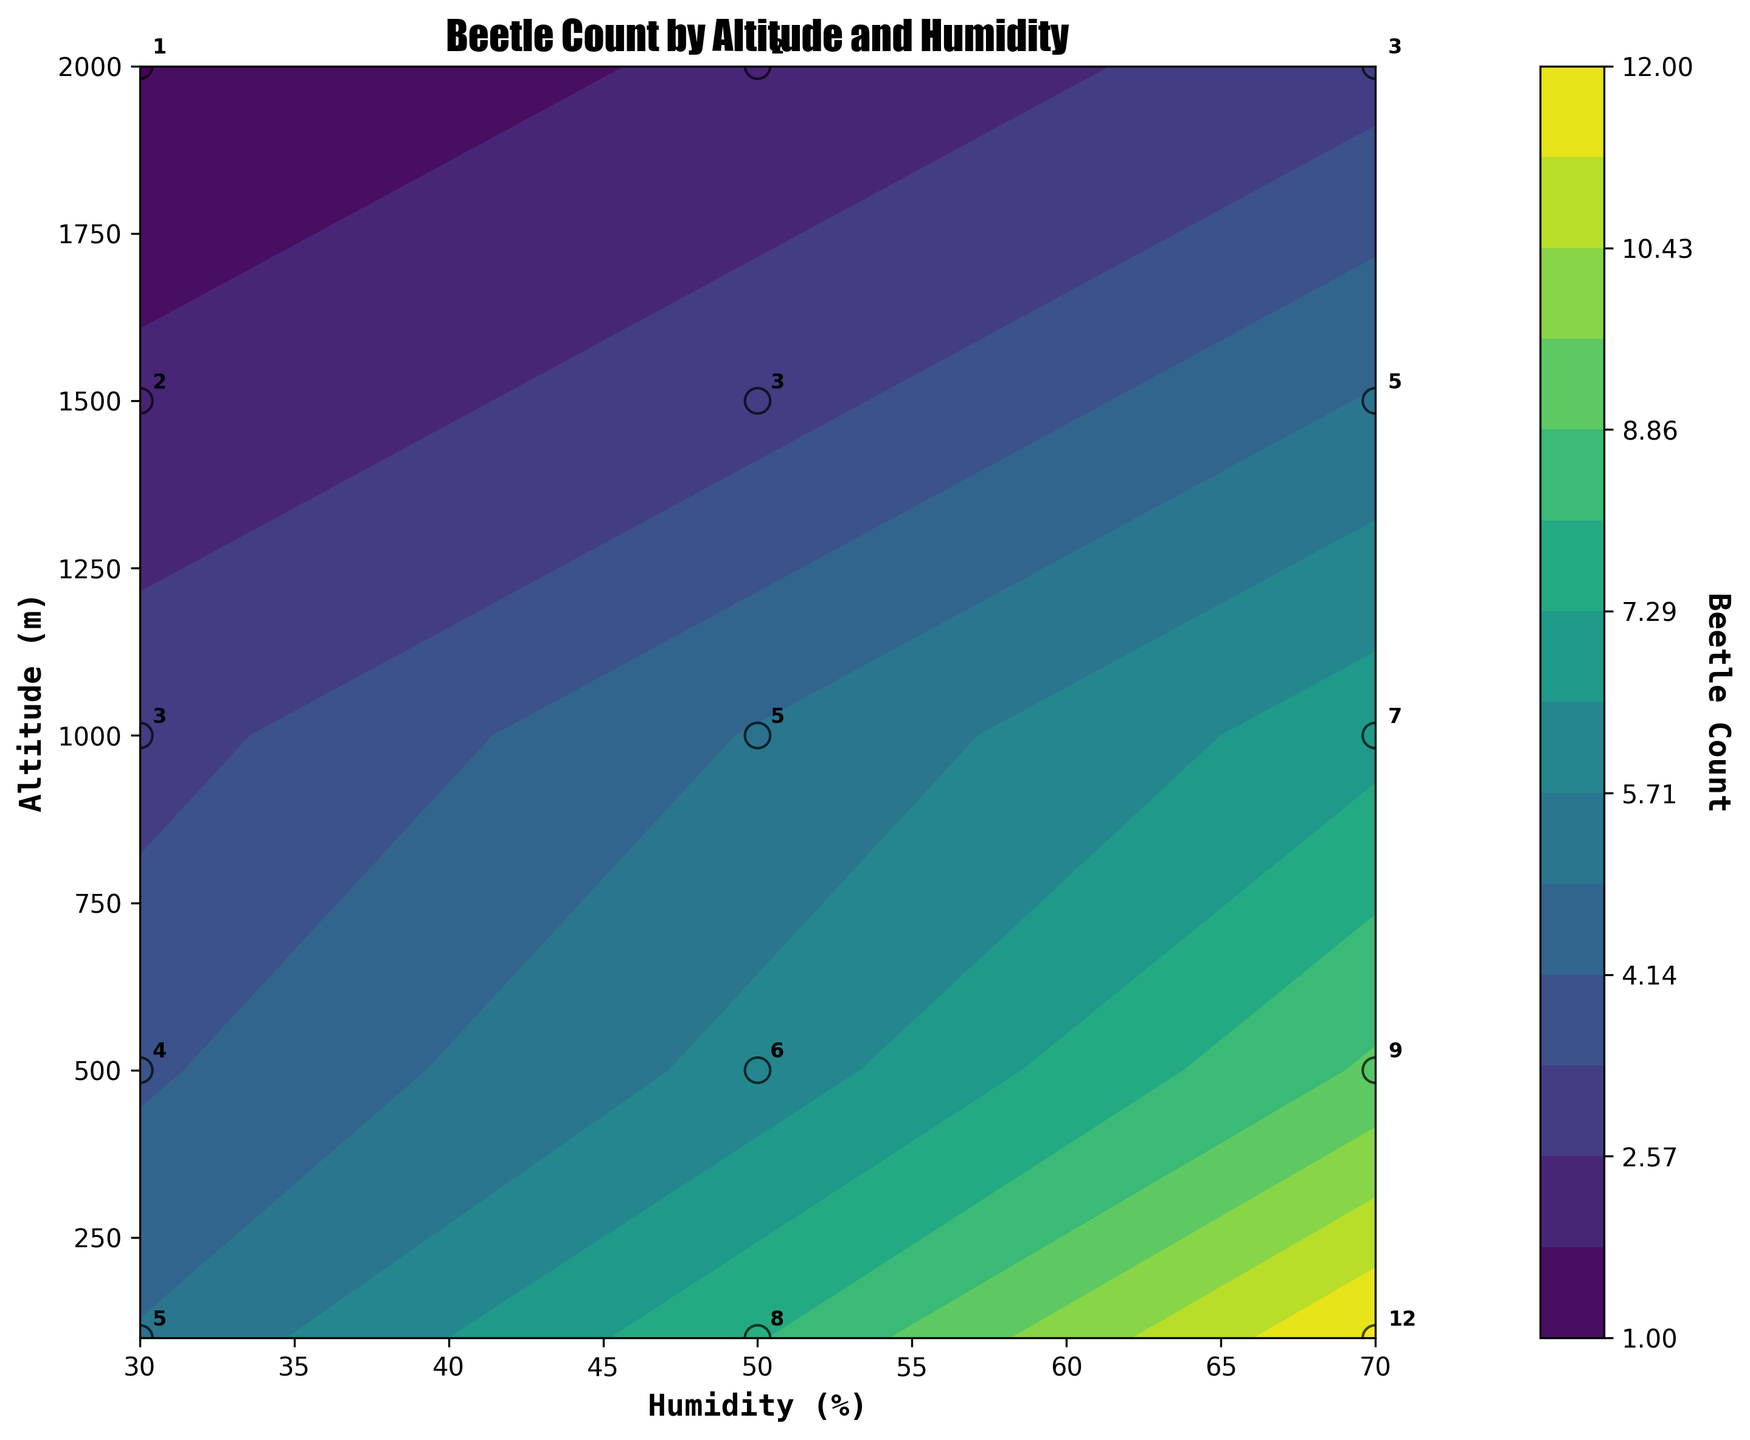Why do some areas of the contour plot have darker shades of color? Darker shades in the contour plot indicate higher beetle counts. The color intensity increases as the count increases, providing a visual representation of beetle abundance in different regions.
Answer: Higher beetle counts What is the title of the contour plot? The title of the contour plot can be found at the top of the figure. It summarizes the main subject of the plot, which is the distribution of beetle counts across various altitudes and humidity levels.
Answer: Beetle Count by Altitude and Humidity At which altitude does the count of beetles range from low to high as humidity increases? To determine this, observe the altitude lines on the y-axis and see how the count changes across different humidity levels on the x-axis. For instance, at 100 meters altitude, the beetle count increases from lower to higher as you move right along the humidity axis from 30% to 70%.
Answer: 100 meters Which altitude-humidity combination has the maximum beetle count, and what is this count? Look at the contour plot and find the darkest color, which indicates the highest beetle count. You'll need to identify the specific altitude and humidity corresponding to this dark shade, and then read the annotated number. The highest count is found at 100 meters altitude and 70% humidity.
Answer: 100m altitude, 70% humidity; 12 beetles How does the beetle count at 500 meters and 70% humidity compare to that at 1500 meters and 70% humidity? To compare these values, locate both points on the plot and note the beetle counts. At 500 meters and 70% humidity, the beetle count is higher, while at 1500 meters and 70% humidity, it's lower. Specifically, 500 meters has a count of 9, and 1500 meters has a count of 5.
Answer: 500m has more beetles Which data point shows the lowest beetle count, and what is the value? Find the lightest shade in the plot, which corresponds to the lowest beetle count. Then identify the altitude and humidity for this point. The lightest area is at 2000 meters altitude and 30% humidity, with a count of 1.
Answer: 2000m, 30% humidity; 1 beetle How does the beetle count trend change with altitude at 50% humidity? Observe the plot along the 50% humidity line and note the changes in beetle counts as altitude increases. The count starts higher at 100 meters and gradually decreases as altitude increases to 2000 meters.
Answer: Decreases with altitude What is the beetle count at 1000 meters and 30% humidity? To find this, locate the point where the altitude is 1000 meters and the humidity is 30%, then read the annotated beetle count.
Answer: 3 beetles What is the average beetle count across all altitudes at 70% humidity? Add the beetle counts at 70% humidity across all altitudes (100m: 12, 500m: 9, 1000m: 7, 1500m: 5, 2000m: 3), and then divide by the number of altitudes. (12+9+7+5+3) / 5 = 36 / 5 = 7.2
Answer: 7.2 beetles Which altitude has the most consistent beetle count across different humidity levels? Look at the beetle counts for each altitude level across different humidity percentages and find the altitude with the least variation in beetle counts. Altitude 1000m has consistent counts of 3, 5, and 7 across humidity levels.
Answer: 1000 meters 